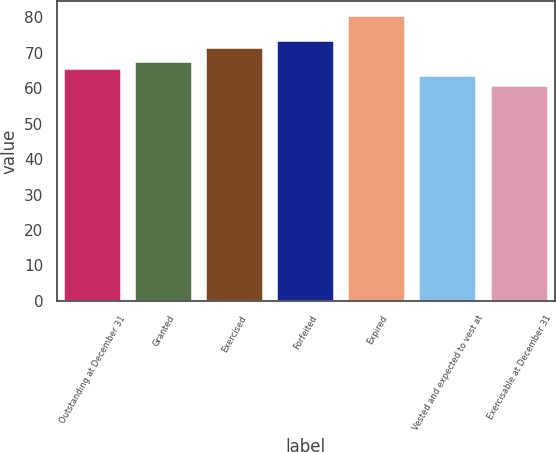Convert chart to OTSL. <chart><loc_0><loc_0><loc_500><loc_500><bar_chart><fcel>Outstanding at December 31<fcel>Granted<fcel>Exercised<fcel>Forfeited<fcel>Expired<fcel>Vested and expected to vest at<fcel>Exercisable at December 31<nl><fcel>65.49<fcel>67.47<fcel>71.43<fcel>73.41<fcel>80.48<fcel>63.51<fcel>60.66<nl></chart> 